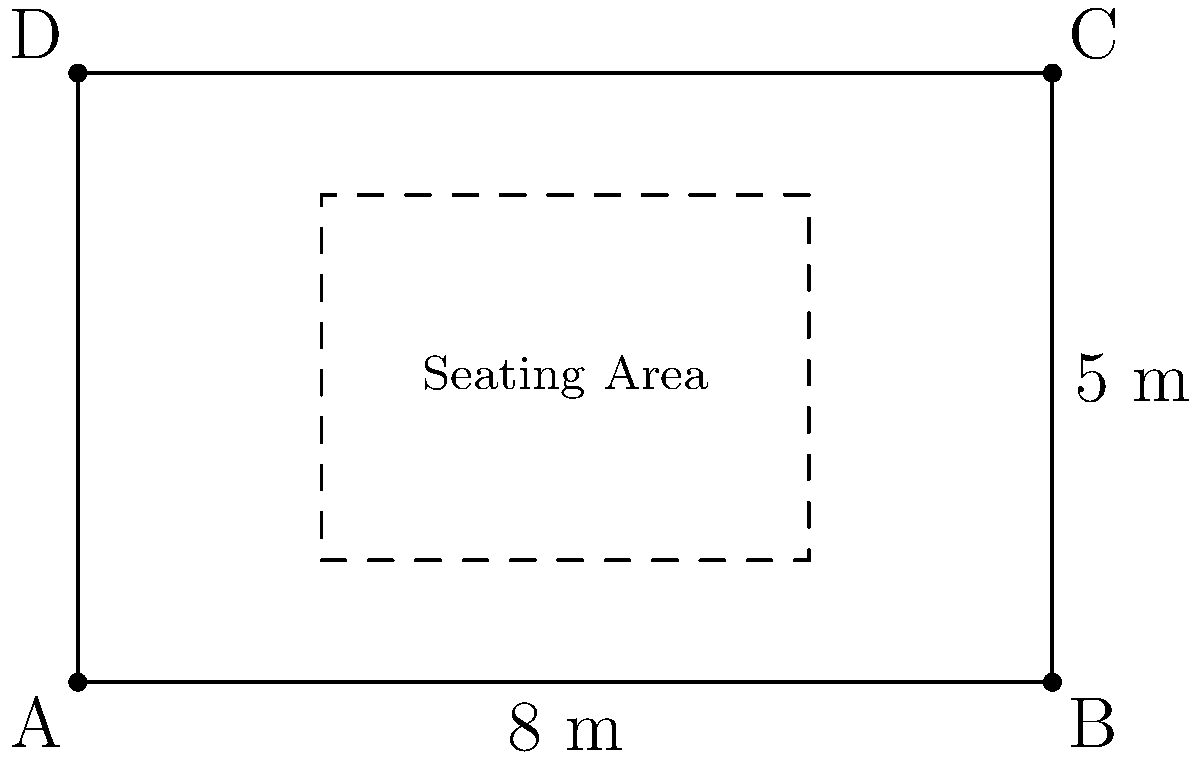You want to redesign your rectangular patio for better feng shui. The patio measures 8 meters long and 5 meters wide. You plan to create a central seating area, leaving a 2-meter walkway around all sides for improved energy flow. What is the area, in square meters, of the central seating area? To find the area of the central seating area, we need to follow these steps:

1) First, calculate the dimensions of the seating area:
   - Length of seating area = Total length - (2 × walkway width)
   - $8 - (2 \times 2) = 4$ meters
   - Width of seating area = Total width - (2 × walkway width)
   - $5 - (2 \times 2) = 1$ meter

2) Now that we have the dimensions of the seating area, we can calculate its area:
   - Area of rectangle = length × width
   - Area of seating area = $4 \times 1 = 4$ square meters

Therefore, the area of the central seating area is 4 square meters.
Answer: $4 \text{ m}^2$ 